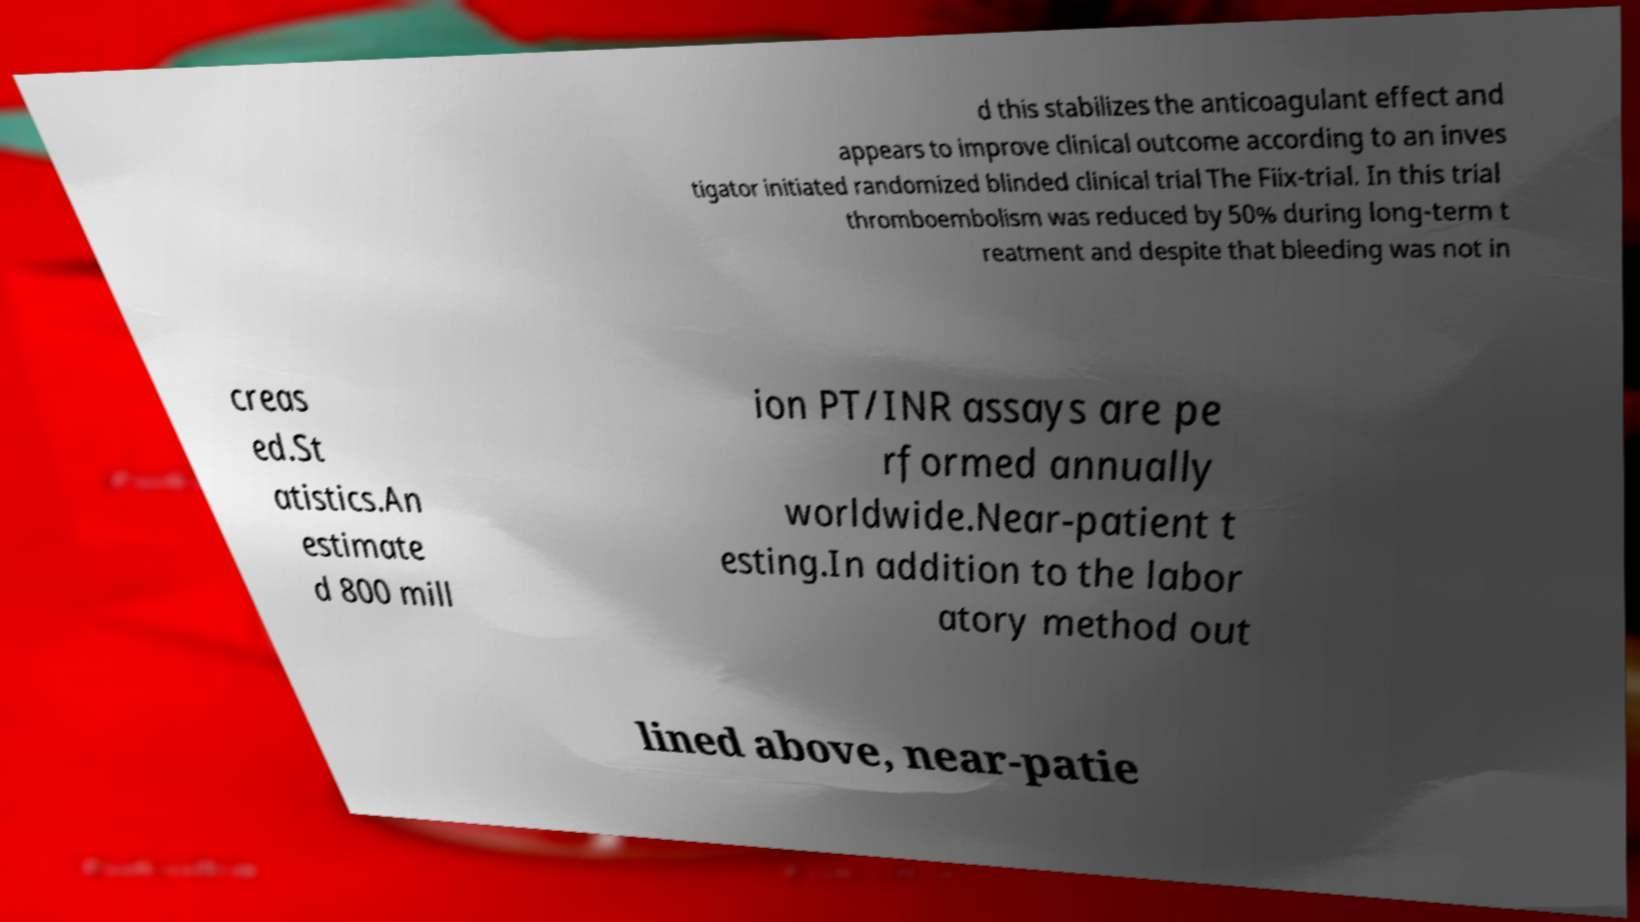For documentation purposes, I need the text within this image transcribed. Could you provide that? d this stabilizes the anticoagulant effect and appears to improve clinical outcome according to an inves tigator initiated randomized blinded clinical trial The Fiix-trial. In this trial thromboembolism was reduced by 50% during long-term t reatment and despite that bleeding was not in creas ed.St atistics.An estimate d 800 mill ion PT/INR assays are pe rformed annually worldwide.Near-patient t esting.In addition to the labor atory method out lined above, near-patie 